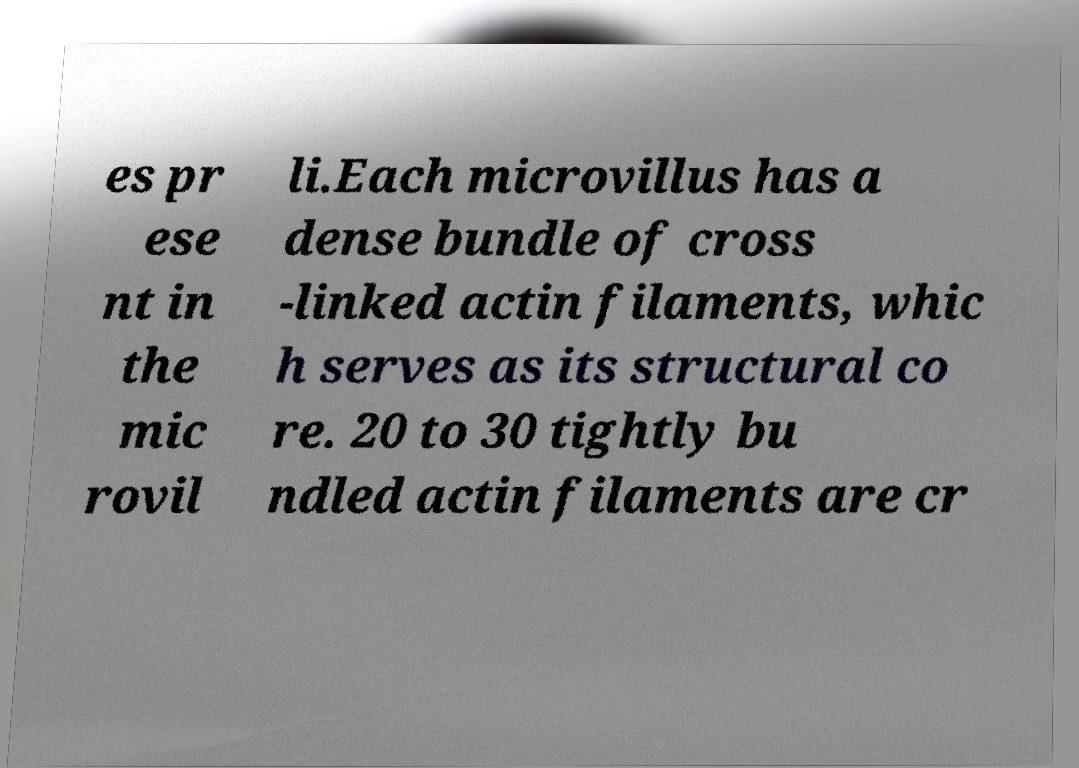Please read and relay the text visible in this image. What does it say? es pr ese nt in the mic rovil li.Each microvillus has a dense bundle of cross -linked actin filaments, whic h serves as its structural co re. 20 to 30 tightly bu ndled actin filaments are cr 